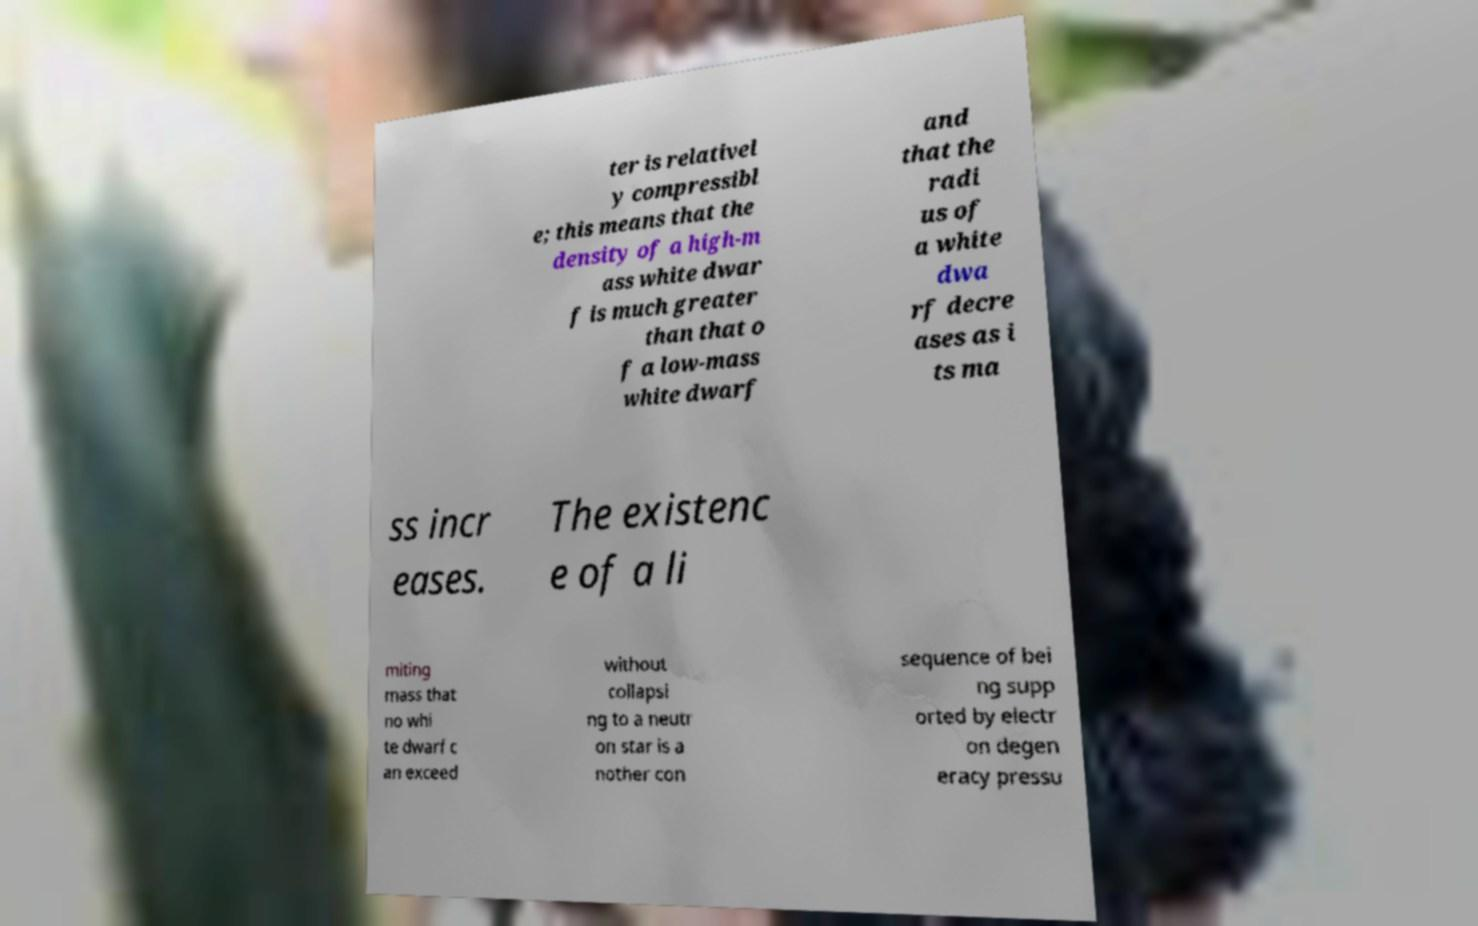Please identify and transcribe the text found in this image. ter is relativel y compressibl e; this means that the density of a high-m ass white dwar f is much greater than that o f a low-mass white dwarf and that the radi us of a white dwa rf decre ases as i ts ma ss incr eases. The existenc e of a li miting mass that no whi te dwarf c an exceed without collapsi ng to a neutr on star is a nother con sequence of bei ng supp orted by electr on degen eracy pressu 